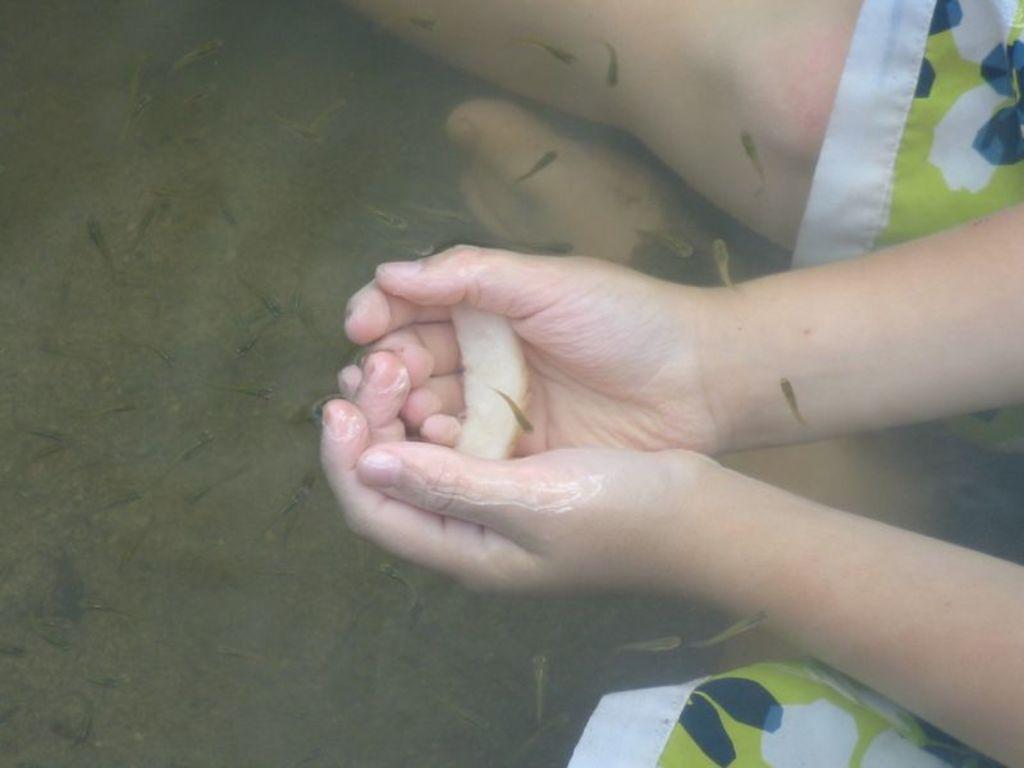Please provide a concise description of this image. In this image there is a person in the water body holding something. In the water there are many small fishes. 